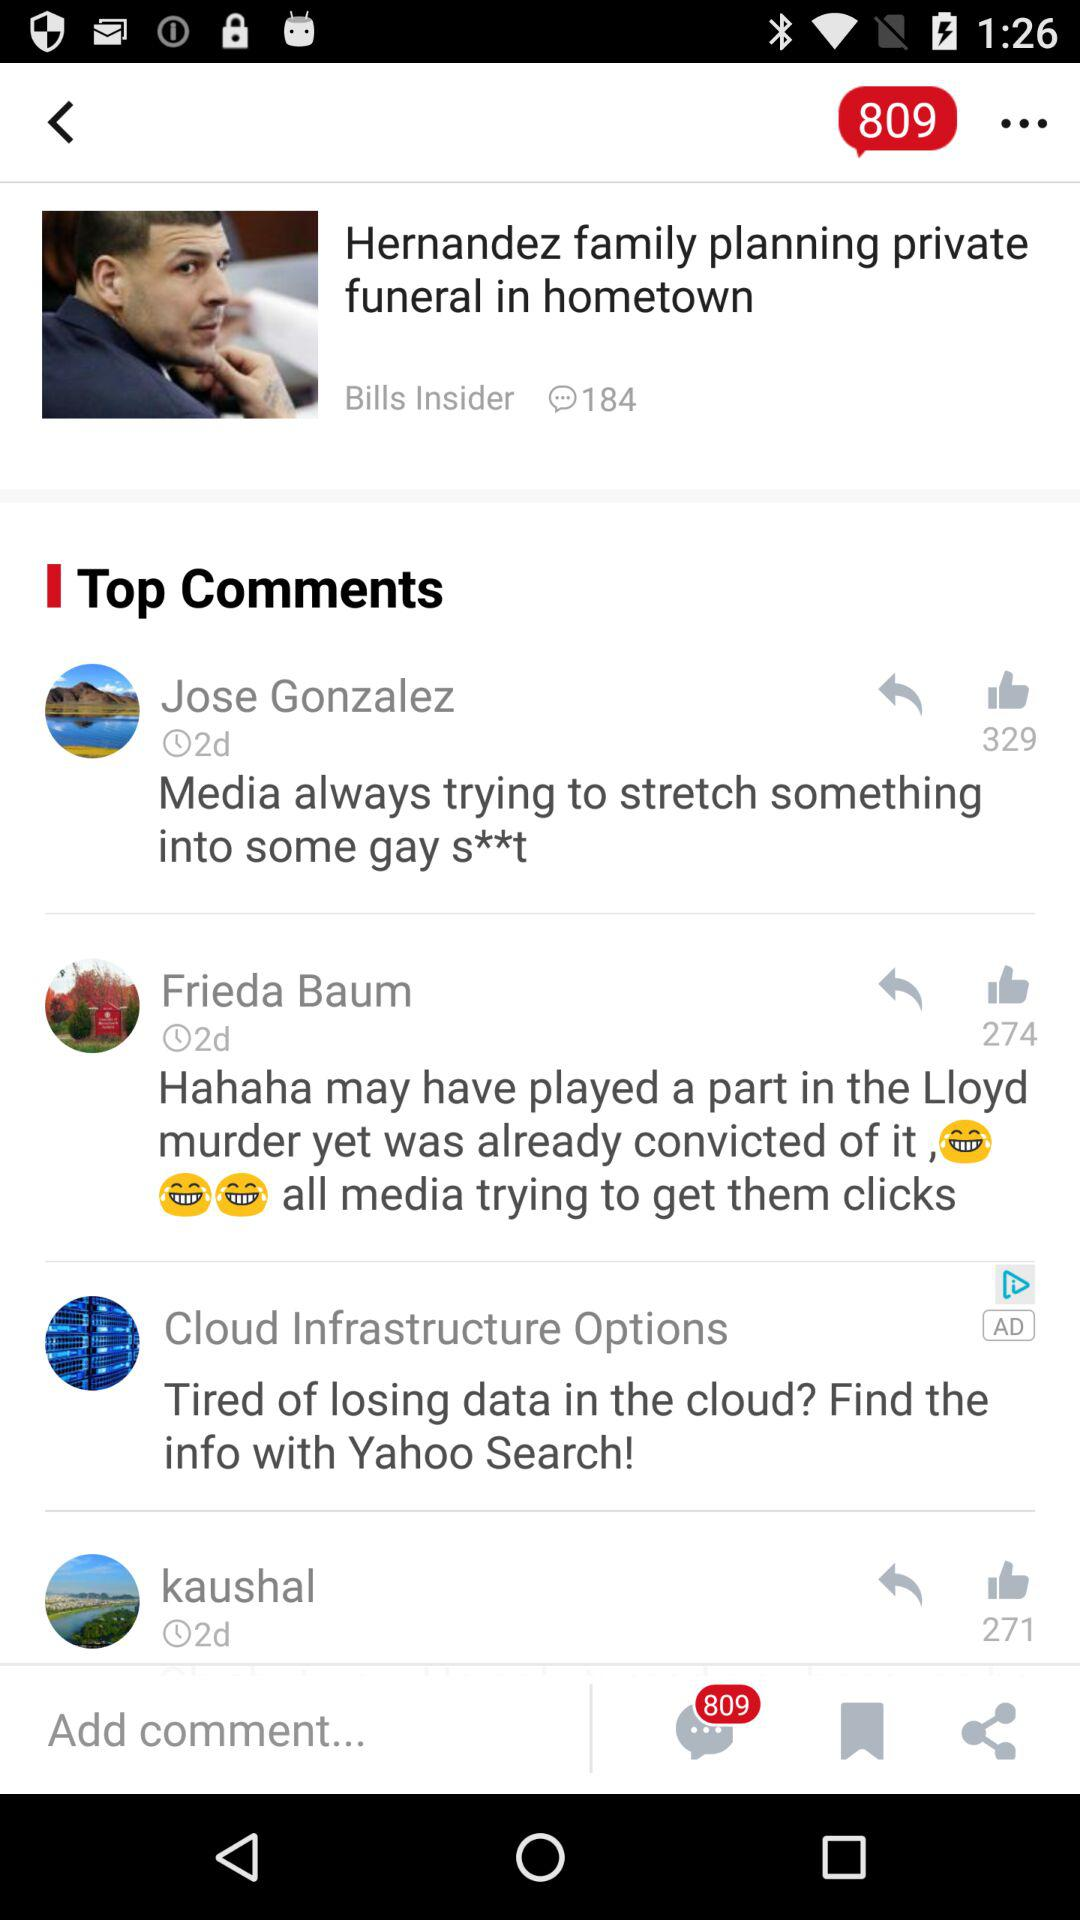How many days ago did Jose Gonzalez post the comment? Jose Gonzalez posted the comment 2 days ago. 